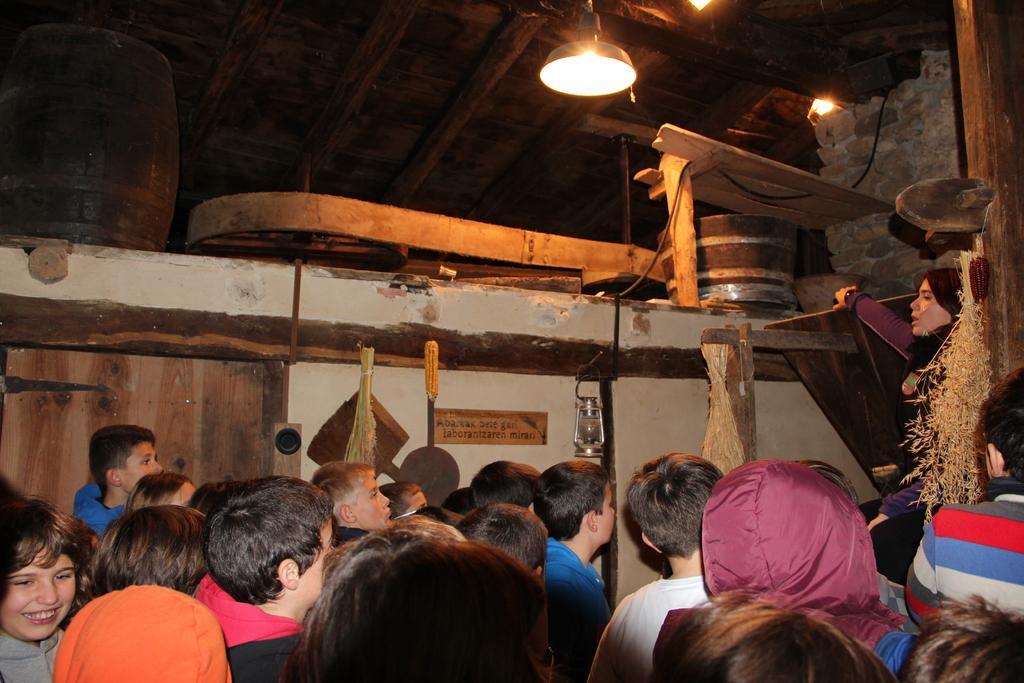How would you summarize this image in a sentence or two? In the given image i can see a people,lamp,board,lights and wooden objects. 